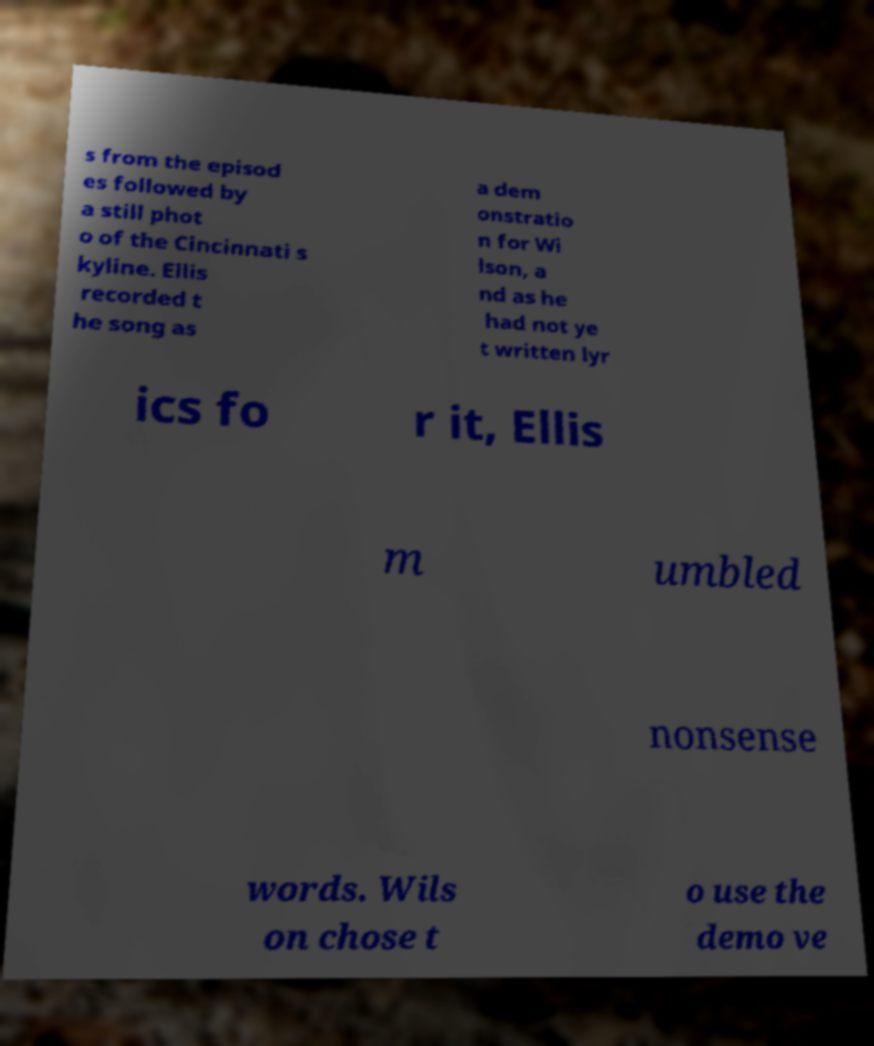Could you assist in decoding the text presented in this image and type it out clearly? s from the episod es followed by a still phot o of the Cincinnati s kyline. Ellis recorded t he song as a dem onstratio n for Wi lson, a nd as he had not ye t written lyr ics fo r it, Ellis m umbled nonsense words. Wils on chose t o use the demo ve 